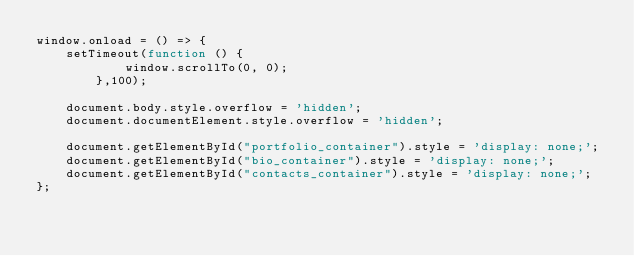Convert code to text. <code><loc_0><loc_0><loc_500><loc_500><_JavaScript_>window.onload = () => {
    setTimeout(function () {
            window.scrollTo(0, 0);
        },100);
    
    document.body.style.overflow = 'hidden';
    document.documentElement.style.overflow = 'hidden';
    
    document.getElementById("portfolio_container").style = 'display: none;';    
    document.getElementById("bio_container").style = 'display: none;';
    document.getElementById("contacts_container").style = 'display: none;';
};</code> 